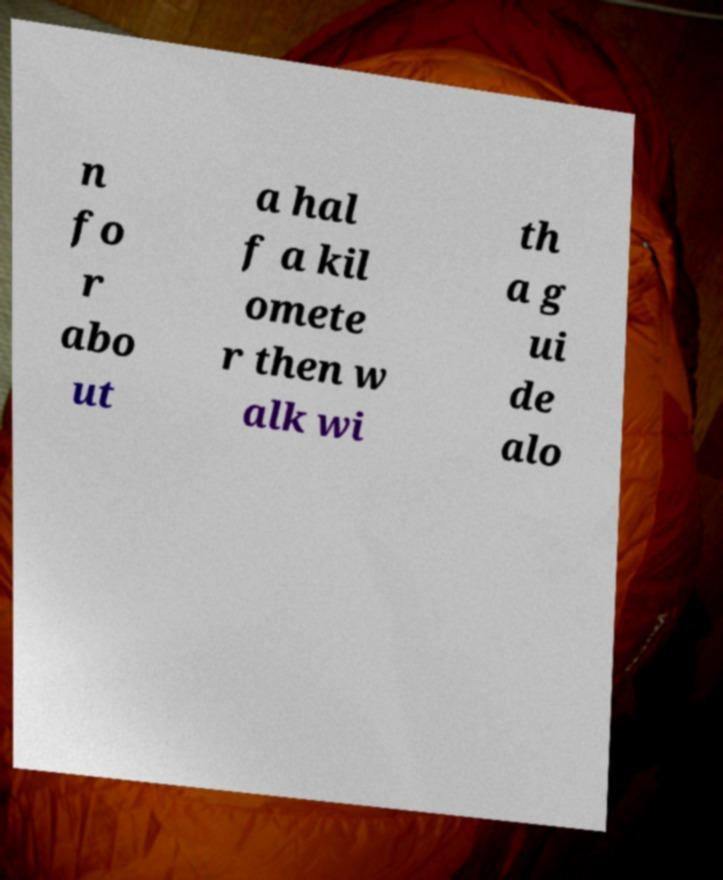I need the written content from this picture converted into text. Can you do that? n fo r abo ut a hal f a kil omete r then w alk wi th a g ui de alo 